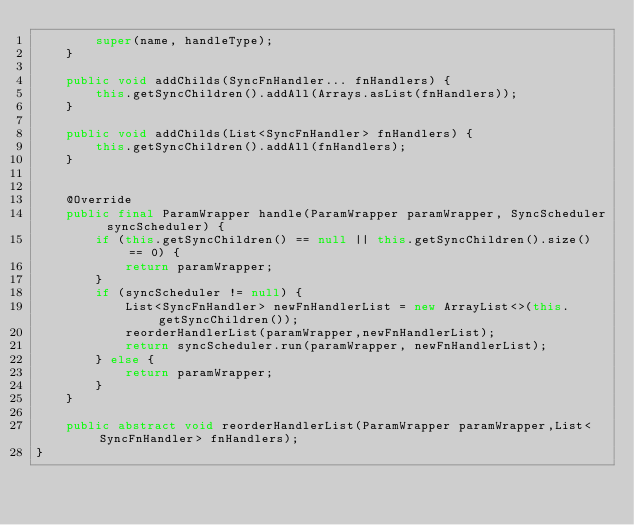Convert code to text. <code><loc_0><loc_0><loc_500><loc_500><_Java_>        super(name, handleType);
    }

    public void addChilds(SyncFnHandler... fnHandlers) {
        this.getSyncChildren().addAll(Arrays.asList(fnHandlers));
    }

    public void addChilds(List<SyncFnHandler> fnHandlers) {
        this.getSyncChildren().addAll(fnHandlers);
    }


    @Override
    public final ParamWrapper handle(ParamWrapper paramWrapper, SyncScheduler syncScheduler) {
        if (this.getSyncChildren() == null || this.getSyncChildren().size() == 0) {
            return paramWrapper;
        }
        if (syncScheduler != null) {
            List<SyncFnHandler> newFnHandlerList = new ArrayList<>(this.getSyncChildren());
            reorderHandlerList(paramWrapper,newFnHandlerList);
            return syncScheduler.run(paramWrapper, newFnHandlerList);
        } else {
            return paramWrapper;
        }
    }

    public abstract void reorderHandlerList(ParamWrapper paramWrapper,List<SyncFnHandler> fnHandlers);
}
</code> 